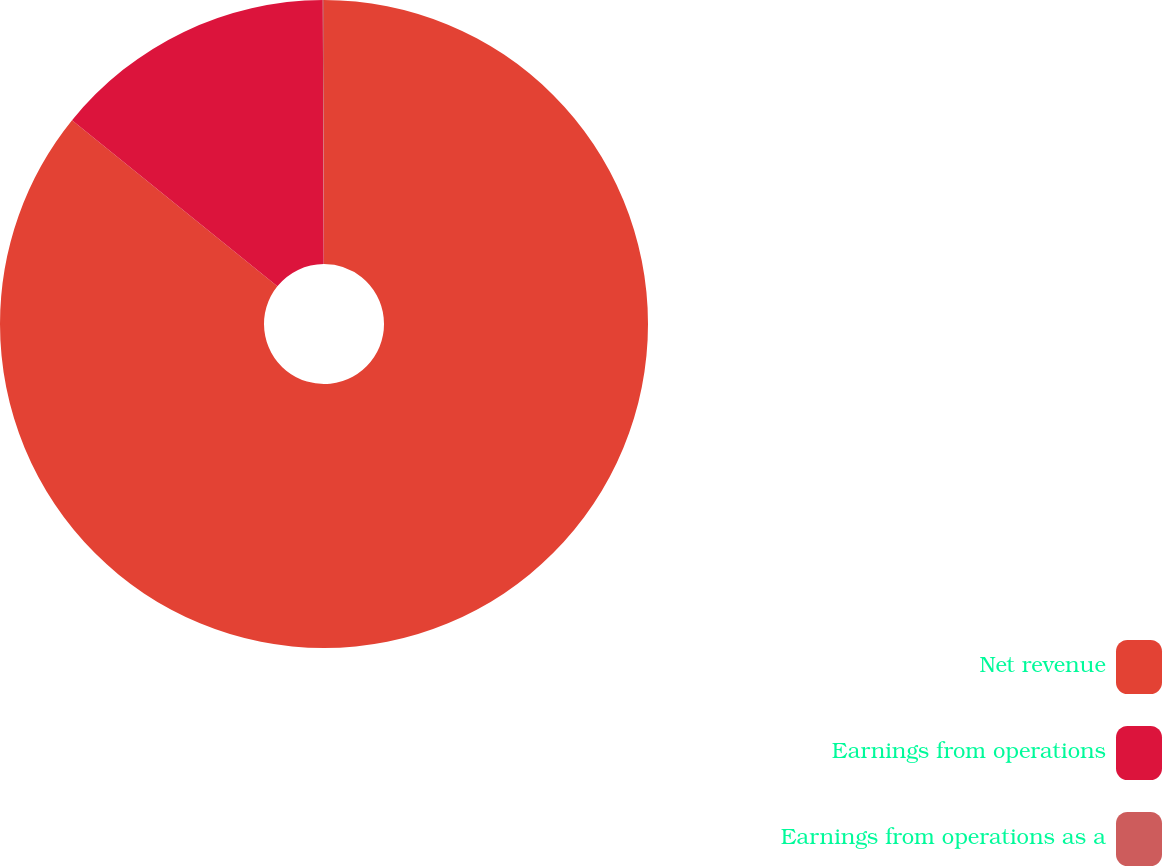<chart> <loc_0><loc_0><loc_500><loc_500><pie_chart><fcel>Net revenue<fcel>Earnings from operations<fcel>Earnings from operations as a<nl><fcel>85.82%<fcel>14.12%<fcel>0.06%<nl></chart> 